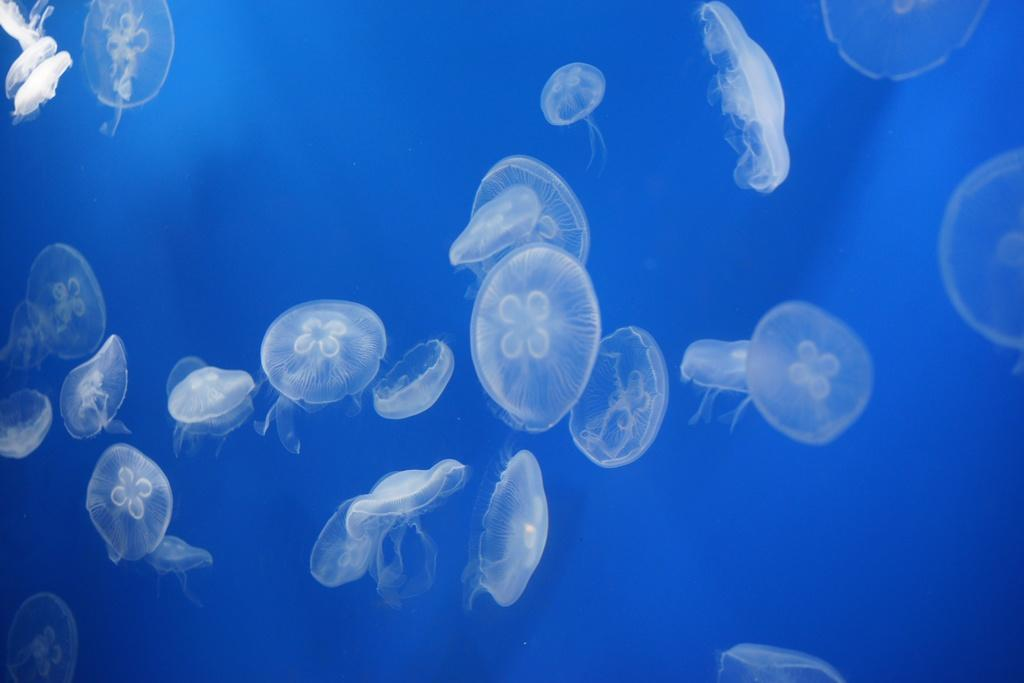What type of sea creatures are in the image? There are jellyfishes in the image. What color is the background of the image? The background of the image is blue. What type of flowers can be seen growing in the image? There are no flowers present in the image; it features jellyfishes in a blue background. What kind of wealth-generating apparatus is visible in the image? There is no wealth-generating apparatus present in the image. 